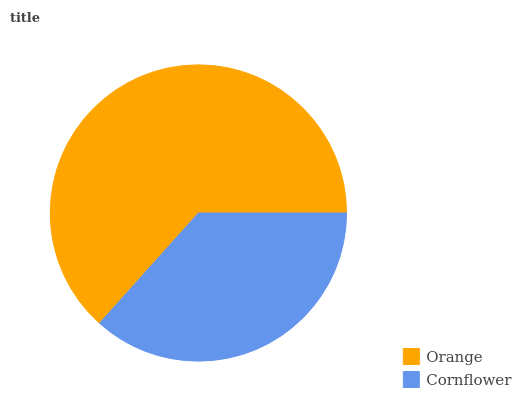Is Cornflower the minimum?
Answer yes or no. Yes. Is Orange the maximum?
Answer yes or no. Yes. Is Cornflower the maximum?
Answer yes or no. No. Is Orange greater than Cornflower?
Answer yes or no. Yes. Is Cornflower less than Orange?
Answer yes or no. Yes. Is Cornflower greater than Orange?
Answer yes or no. No. Is Orange less than Cornflower?
Answer yes or no. No. Is Orange the high median?
Answer yes or no. Yes. Is Cornflower the low median?
Answer yes or no. Yes. Is Cornflower the high median?
Answer yes or no. No. Is Orange the low median?
Answer yes or no. No. 